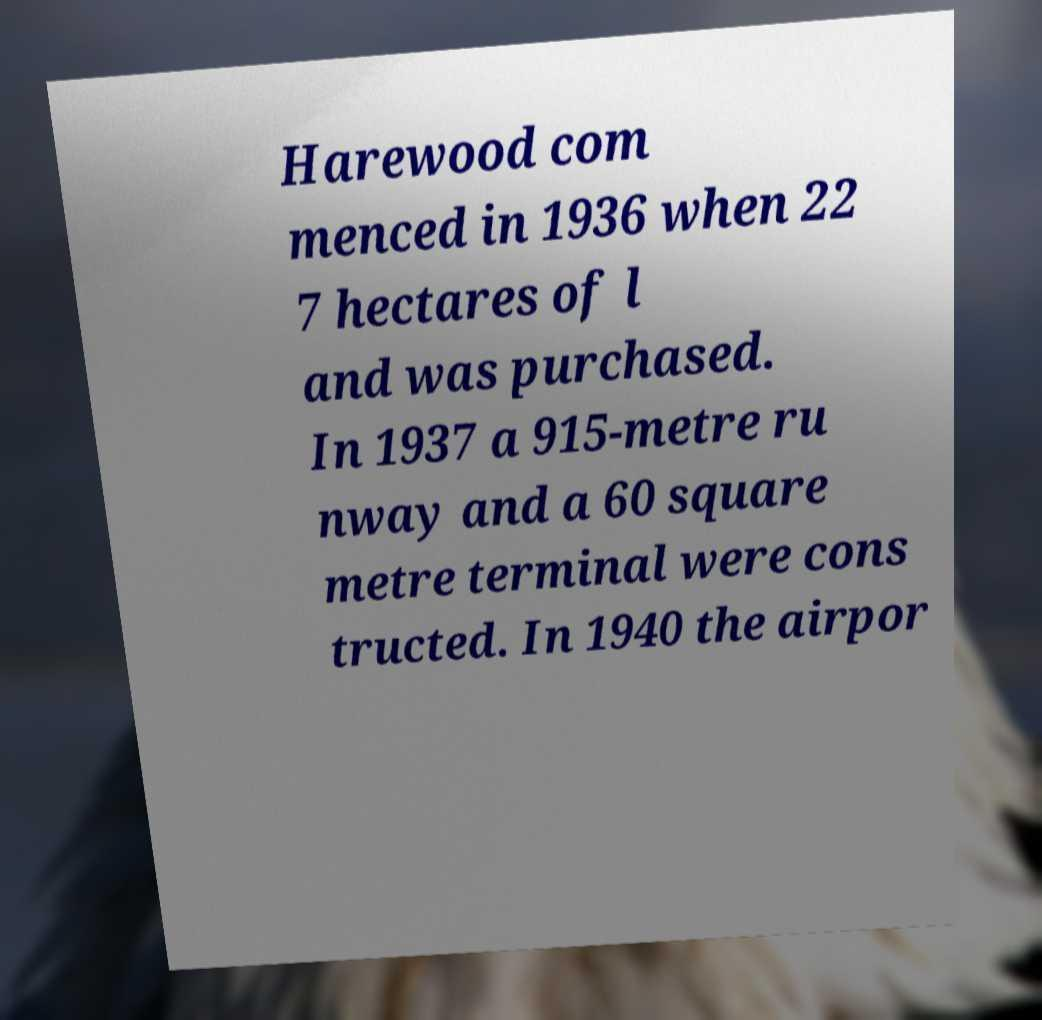What messages or text are displayed in this image? I need them in a readable, typed format. Harewood com menced in 1936 when 22 7 hectares of l and was purchased. In 1937 a 915-metre ru nway and a 60 square metre terminal were cons tructed. In 1940 the airpor 